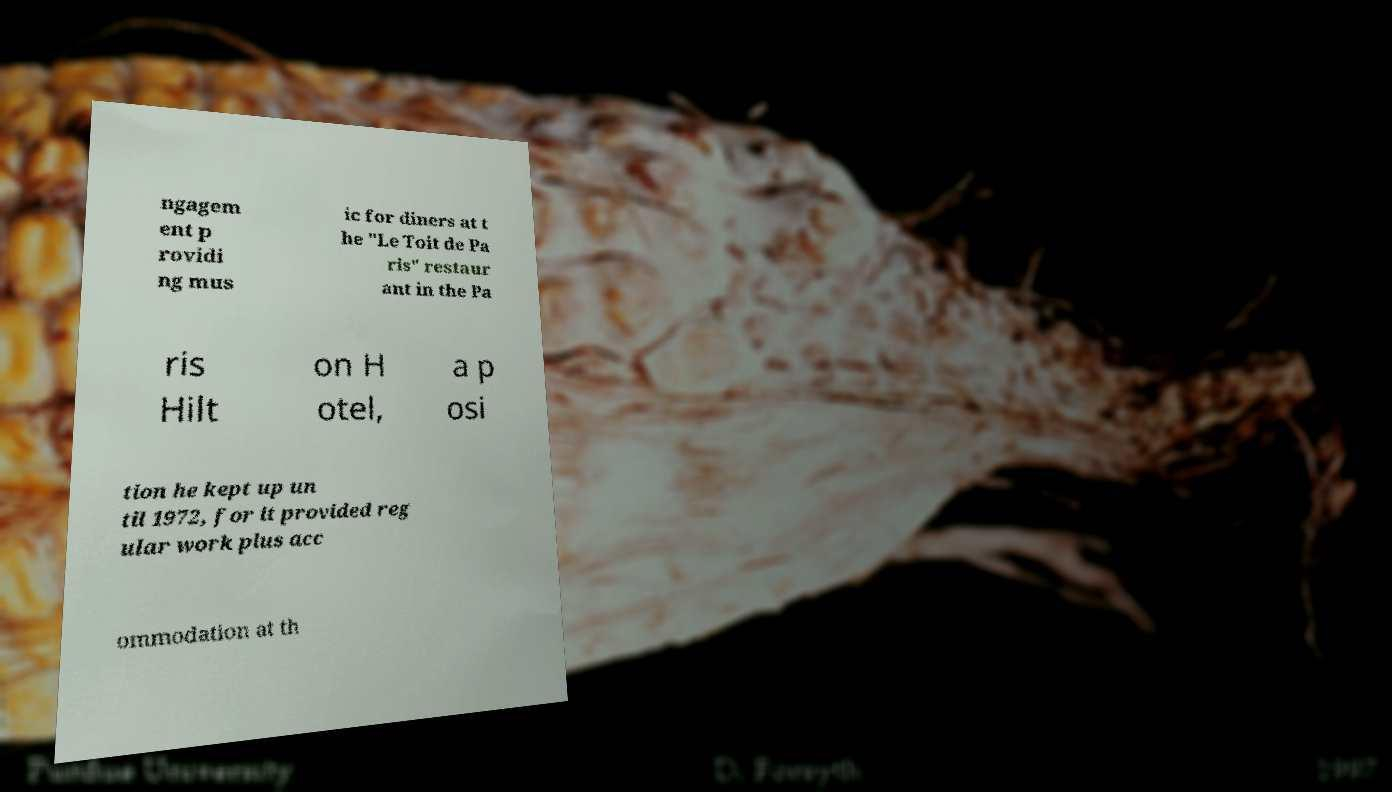Please read and relay the text visible in this image. What does it say? ngagem ent p rovidi ng mus ic for diners at t he "Le Toit de Pa ris" restaur ant in the Pa ris Hilt on H otel, a p osi tion he kept up un til 1972, for it provided reg ular work plus acc ommodation at th 